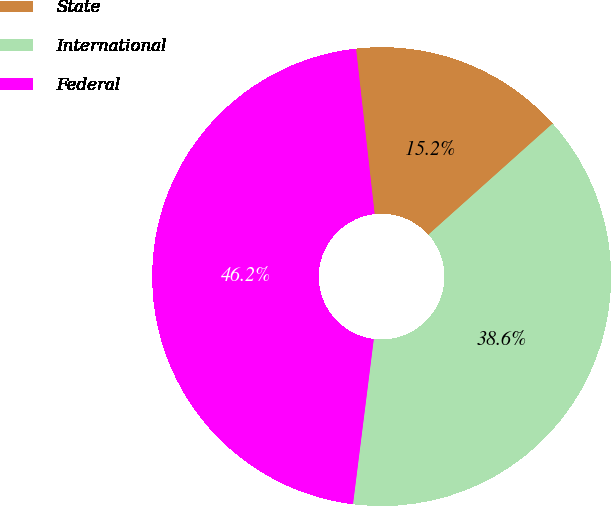<chart> <loc_0><loc_0><loc_500><loc_500><pie_chart><fcel>State<fcel>International<fcel>Federal<nl><fcel>15.17%<fcel>38.61%<fcel>46.22%<nl></chart> 